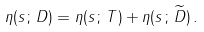<formula> <loc_0><loc_0><loc_500><loc_500>\eta ( s \, ; \, D ) = \eta ( s \, ; \, T ) + \eta ( s \, ; \, \widetilde { D } ) \, .</formula> 